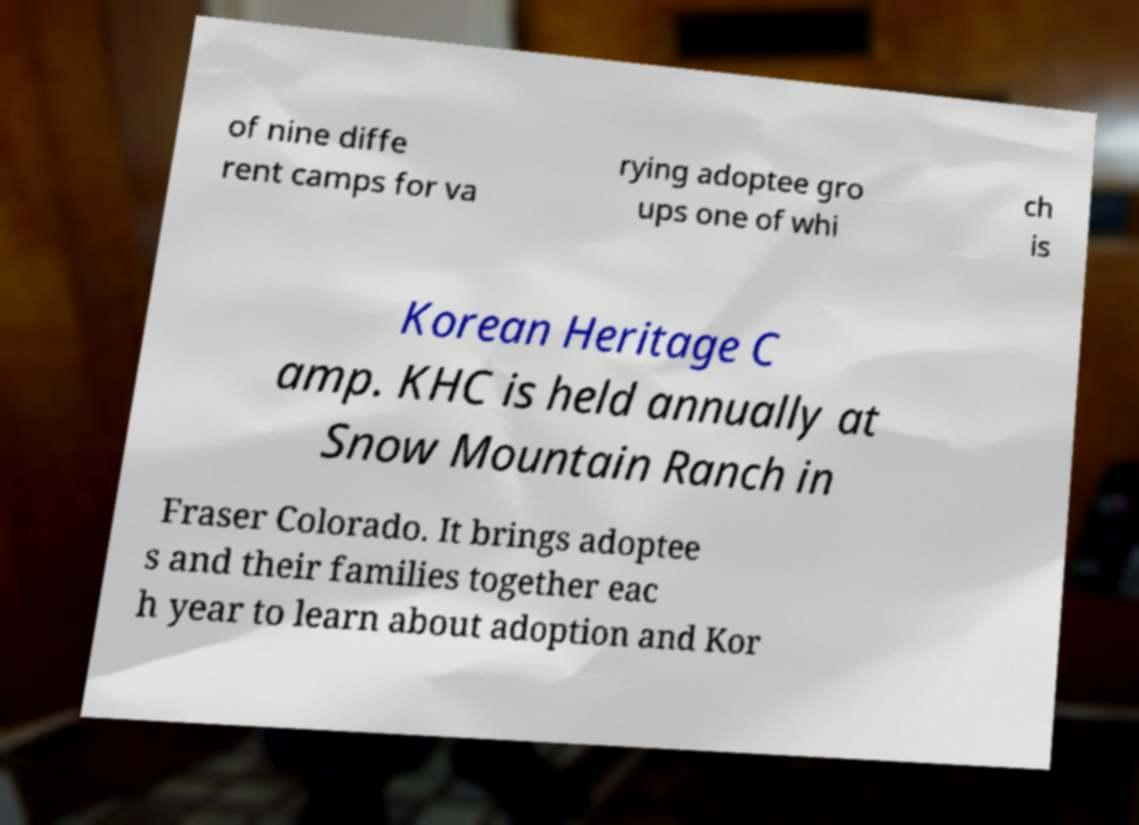What messages or text are displayed in this image? I need them in a readable, typed format. of nine diffe rent camps for va rying adoptee gro ups one of whi ch is Korean Heritage C amp. KHC is held annually at Snow Mountain Ranch in Fraser Colorado. It brings adoptee s and their families together eac h year to learn about adoption and Kor 